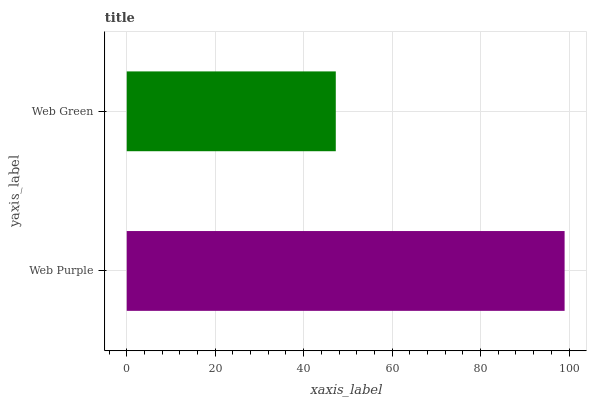Is Web Green the minimum?
Answer yes or no. Yes. Is Web Purple the maximum?
Answer yes or no. Yes. Is Web Green the maximum?
Answer yes or no. No. Is Web Purple greater than Web Green?
Answer yes or no. Yes. Is Web Green less than Web Purple?
Answer yes or no. Yes. Is Web Green greater than Web Purple?
Answer yes or no. No. Is Web Purple less than Web Green?
Answer yes or no. No. Is Web Purple the high median?
Answer yes or no. Yes. Is Web Green the low median?
Answer yes or no. Yes. Is Web Green the high median?
Answer yes or no. No. Is Web Purple the low median?
Answer yes or no. No. 